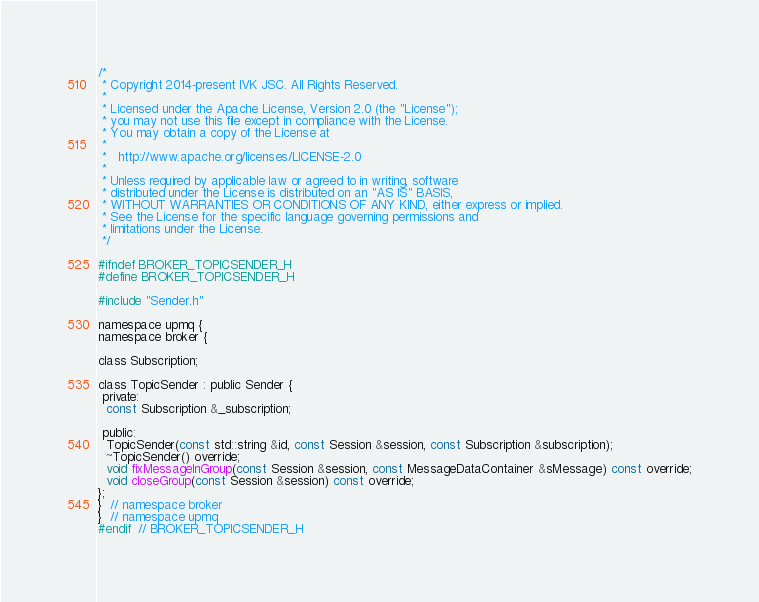<code> <loc_0><loc_0><loc_500><loc_500><_C_>/*
 * Copyright 2014-present IVK JSC. All Rights Reserved.
 *
 * Licensed under the Apache License, Version 2.0 (the "License");
 * you may not use this file except in compliance with the License.
 * You may obtain a copy of the License at
 *
 *   http://www.apache.org/licenses/LICENSE-2.0
 *
 * Unless required by applicable law or agreed to in writing, software
 * distributed under the License is distributed on an "AS IS" BASIS,
 * WITHOUT WARRANTIES OR CONDITIONS OF ANY KIND, either express or implied.
 * See the License for the specific language governing permissions and
 * limitations under the License.
 */

#ifndef BROKER_TOPICSENDER_H
#define BROKER_TOPICSENDER_H

#include "Sender.h"

namespace upmq {
namespace broker {

class Subscription;

class TopicSender : public Sender {
 private:
  const Subscription &_subscription;

 public:
  TopicSender(const std::string &id, const Session &session, const Subscription &subscription);
  ~TopicSender() override;
  void fixMessageInGroup(const Session &session, const MessageDataContainer &sMessage) const override;
  void closeGroup(const Session &session) const override;
};
}  // namespace broker
}  // namespace upmq
#endif  // BROKER_TOPICSENDER_H
</code> 